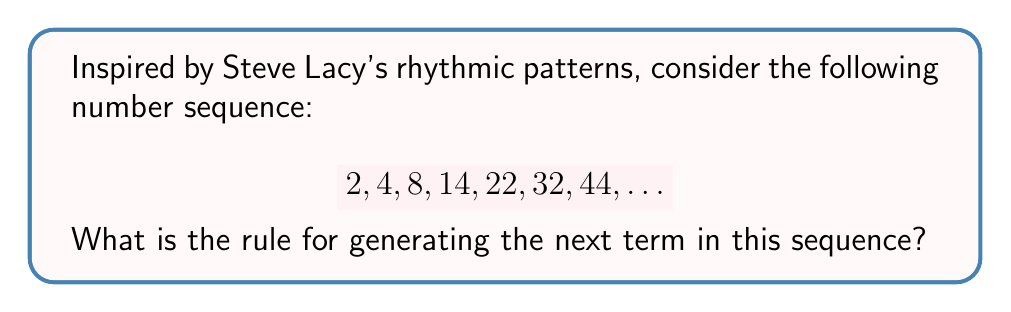Help me with this question. To identify the rule for this sequence, let's analyze the differences between consecutive terms:

1. First, calculate the differences between each pair of consecutive terms:
   $$
   4 - 2 = 2
   8 - 4 = 4
   14 - 8 = 6
   22 - 14 = 8
   32 - 22 = 10
   44 - 32 = 12
   $$

2. Observe that the differences form an arithmetic sequence: 2, 4, 6, 8, 10, 12, ...

3. The difference between each term in this arithmetic sequence is 2.

4. This pattern suggests that to get from one term to the next in the original sequence, we add an increasing odd number:
   - From 2 to 4, we add 2 (1st odd number)
   - From 4 to 8, we add 4 (2nd odd number)
   - From 8 to 14, we add 6 (3rd odd number)
   - And so on...

5. We can express this rule mathematically as:

   $$a_n = a_{n-1} + (2n - 1)$$

   Where $a_n$ is the nth term of the sequence, and $n$ starts at 1.

6. This rule generates the sequence by adding the nth odd number to the previous term.
Answer: $a_n = a_{n-1} + (2n - 1)$ 